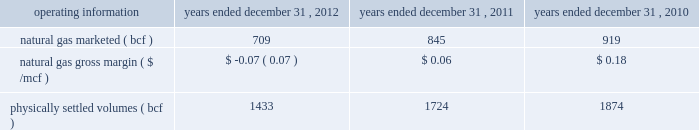Costs .
Our 2012 results were lower than 2011 when we realized $ 53.1 million in premium-services margins and our storage and marketing margins consisted of $ 96.0 million from realized seasonal price differentials and marketing optimization activities , and $ 87.7 million of storage demand costs .
In addition , we recognized a loss on the change in fair value of our nonqualifiying economic storage hedges of $ 1.0 million in 2012 compared with a gain of $ 8.5 million in 2011 .
Our premium services were impacted negatively by lower natural gas prices and decreased natural gas price volatility .
The impact of our hedge strategies and the inability to hedge seasonal price differentials at levels that were available to us in the prior year significantly reduced our storage margins .
We also experienced reduced opportunities to optimize our storage assets , which negatively impacted our marketing margins .
We realized a loss in our transportation margins of $ 42.4 million in 2012 compared with a loss of $ 18.8 million in 2011 , due primarily to a $ 29.5 million decrease in transportation hedges .
Our transportation business continues to be impacted by narrow price location differentials and the inability to hedge at levels that were available to us in prior years .
As a result of significant increases in the supply of natural gas , primarily from shale gas production across north america and new pipeline infrastructure projects , location and seasonal price differentials narrowed significantly beginning in 2010 and continuing through 2012 .
This market change resulted in our transportation contracts being unprofitable impacting our ability to recover our fixed costs .
Operating costs decreased due primarily to lower employee-related expenses , which includes the impact of fewer employees .
We also recognized an expense of $ 10.3 million related to the impairment of our goodwill in the first quarter 2012 .
Given the significant decline in natural gas prices and its effect on location and seasonal price differentials , we performed an interim impairment assessment in the first quarter 2012 that reduced our goodwill balance to zero .
2011 vs .
2010 - the factors discussed in energy services 2019 201cnarrative description of the business 201d included in item i , business , of this annual report have led to a significant decrease in net margin , including : 2022 a decrease of $ 65.3 million in transportation margins , net of hedging , due primarily to narrower location price differentials and lower hedge settlements in 2011 ; 2022 a decrease of $ 34.3 million in storage and marketing margins , net of hedging activities , due primarily to the following : 2013 lower realized seasonal storage price differentials ; offset partially by 2013 favorable marketing activity and unrealized fair value changes on nonqualifying economic storage hedges ; 2022 a decrease of $ 7.3 million in premium-services margins , associated primarily with the reduction in the value of the fees collected for these services as a result of low commodity prices and reduced natural gas price volatility in the first quarter 2011 compared with the first quarter 2010 ; and 2022 a decrease of $ 4.3 million in financial trading margins , as low natural gas prices and reduced natural gas price volatility limited our financial trading opportunities .
Additionally , our 2011 net margin includes $ 91.1 million in adjustments to natural gas inventory reflecting the lower of cost or market value .
Because of the adjustments to our inventory value , we reclassified $ 91.1 million of deferred gains on associated cash flow hedges into earnings .
Operating costs decreased due primarily to a decrease in ad valorem taxes .
Selected operating information - the table sets forth certain selected operating information for our energy services segment for the periods indicated: .
Natural gas volumes marketed and physically settled volumes decreased in 2012 compared with 2011 due primarily to decreased marketing activities , lower transported volumes and reduced transportation capacity .
The decrease in 2011 compared with 2010 was due primarily to lower volumes transported and reduced transportation capacity .
Transportation capacity in certain markets was not utilized due to the economics of the location price differentials as a result of increased supply of natural gas , primarily from shale production , and increased pipeline capacity as a result of new pipeline construction. .
What was the percentage difference in natural gas marketed ( bcf ) between 2011 and 2012? 
Computations: ((709 - 845) / 845)
Answer: -0.16095. 